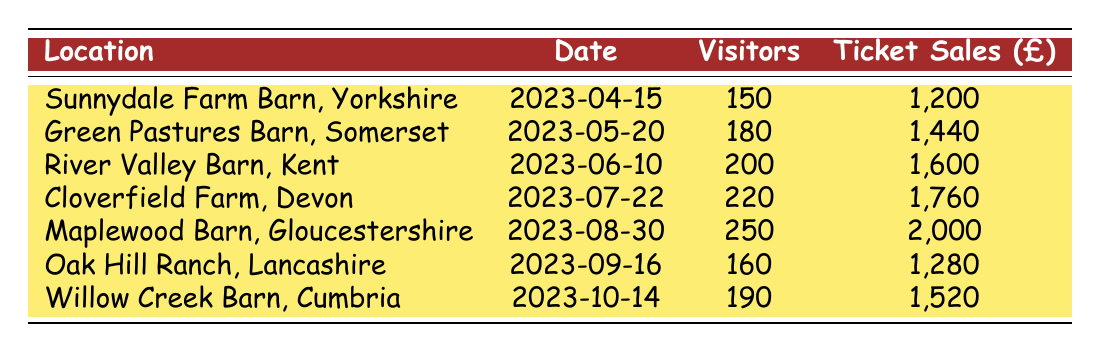What was the highest visitor attendance at the jam sessions? The row with the highest number of visitors shows Maplewood Barn, Gloucestershire, with 250 visitors on 2023-08-30.
Answer: 250 How much were the ticket sales for Cloverfield Farm, Devon? The table lists Cloverfield Farm, Devon's ticket sales as 1,760 on 2023-07-22.
Answer: 1760 Which barn had the least visitor attendance? The least visitor attendance is at Sunnydale Farm Barn, Yorkshire, with 150 visitors on 2023-04-15.
Answer: Sunnydale Farm Barn, Yorkshire What is the total amount of ticket sales from all jam sessions? To find the total, we add up all the ticket sales: 1,200 + 1,440 + 1,600 + 1,760 + 2,000 + 1,280 + 1,520 = 10,800.
Answer: 10800 Is there any session with more than 200 visitors? Yes, Cloverfield Farm, Devon, and Maplewood Barn, Gloucestershire had more than 200 visitors.
Answer: Yes What is the average number of visitors per jam session? To find the average, sum the visitor attendance (150 + 180 + 200 + 220 + 250 + 160 + 190 = 1,350) and divide by 7 (the number of sessions), resulting in 1,350 / 7 = 192.86, which rounds to 193.
Answer: 193 Did the ticket sales increase for each subsequent jam session? No, while the ticket sales generally increased, Oak Hill Ranch, Lancashire, had sales of 1,280, which is less than the 1,600 from River Valley Barn, Kent.
Answer: No What was the increase in ticket sales from the first session to the last session? The first session had ticket sales of 1,200, and the last session had ticket sales of 1,520, resulting in an increase of 1,520 - 1,200 = 320.
Answer: 320 